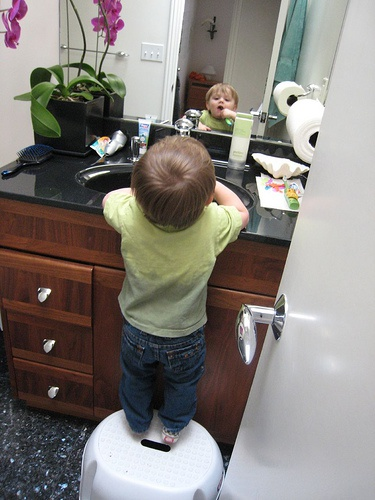Describe the objects in this image and their specific colors. I can see people in lightgray, black, olive, gray, and darkgray tones, potted plant in lightgray, black, darkgreen, and gray tones, sink in lightgray, black, gray, white, and darkgray tones, people in lightgray, tan, gray, and olive tones, and toothbrush in lightgray, lightgreen, khaki, and green tones in this image. 